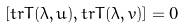Convert formula to latex. <formula><loc_0><loc_0><loc_500><loc_500>[ t r T ( \lambda , u ) , t r T ( \lambda , v ) ] = 0</formula> 